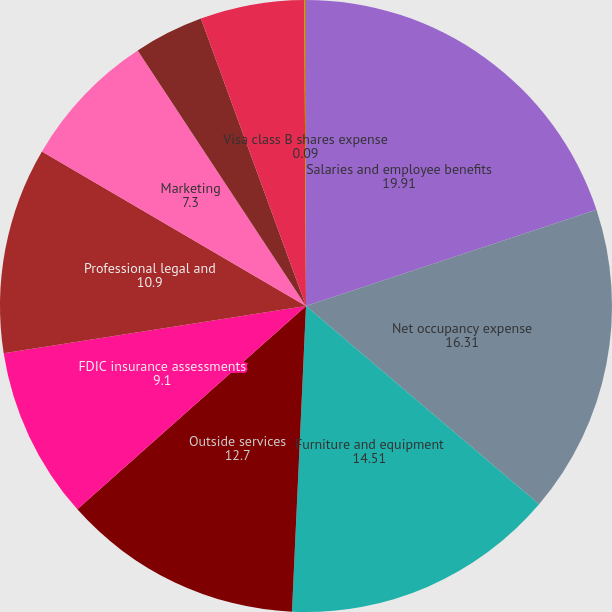Convert chart to OTSL. <chart><loc_0><loc_0><loc_500><loc_500><pie_chart><fcel>Salaries and employee benefits<fcel>Net occupancy expense<fcel>Furniture and equipment<fcel>Outside services<fcel>FDIC insurance assessments<fcel>Professional legal and<fcel>Marketing<fcel>Credit/checkcard expenses<fcel>Branch consolidation property<fcel>Visa class B shares expense<nl><fcel>19.91%<fcel>16.31%<fcel>14.51%<fcel>12.7%<fcel>9.1%<fcel>10.9%<fcel>7.3%<fcel>3.69%<fcel>5.49%<fcel>0.09%<nl></chart> 